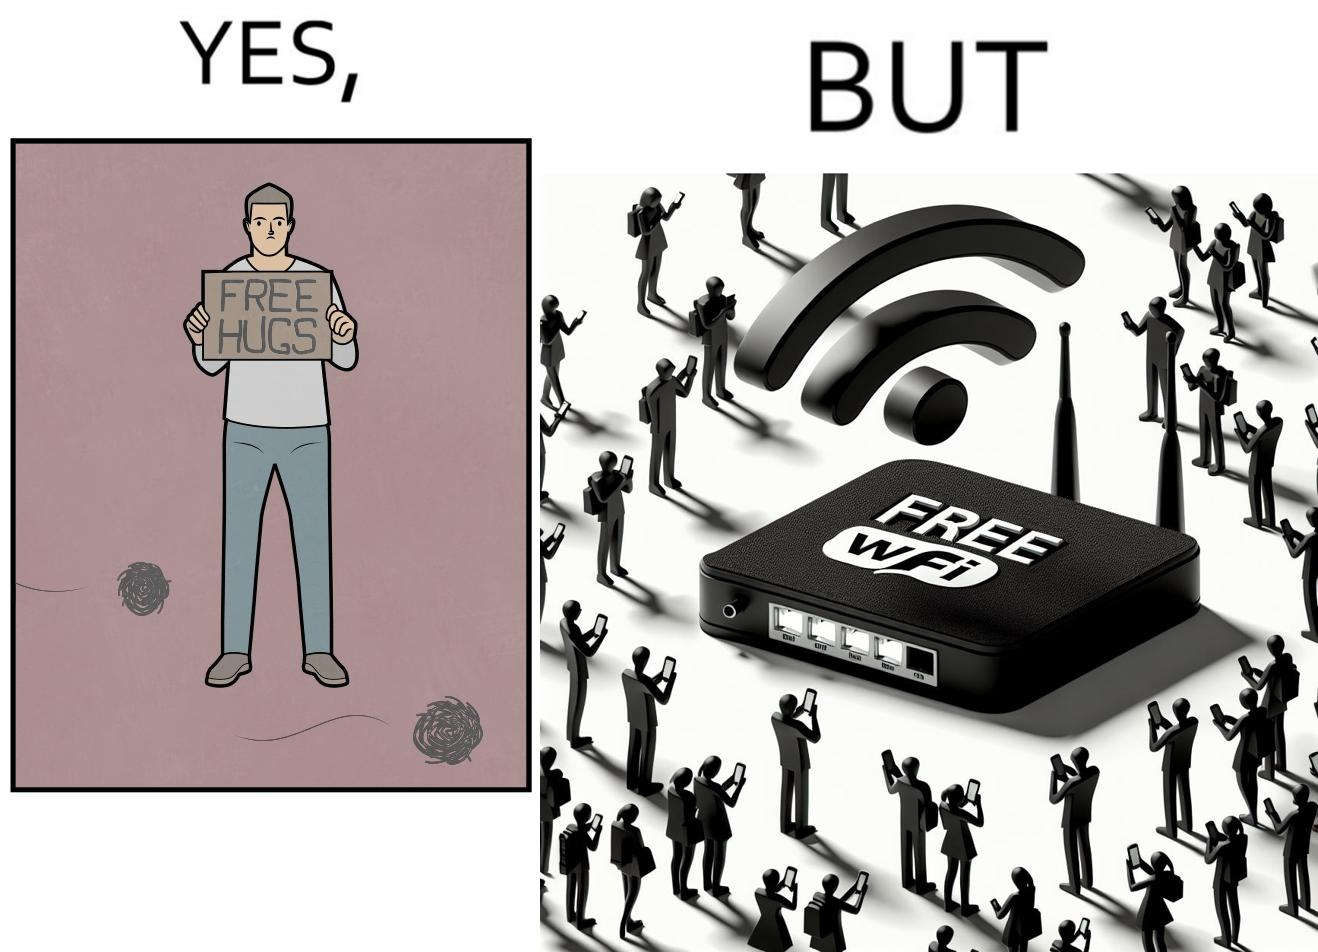Is there satirical content in this image? Yes, this image is satirical. 